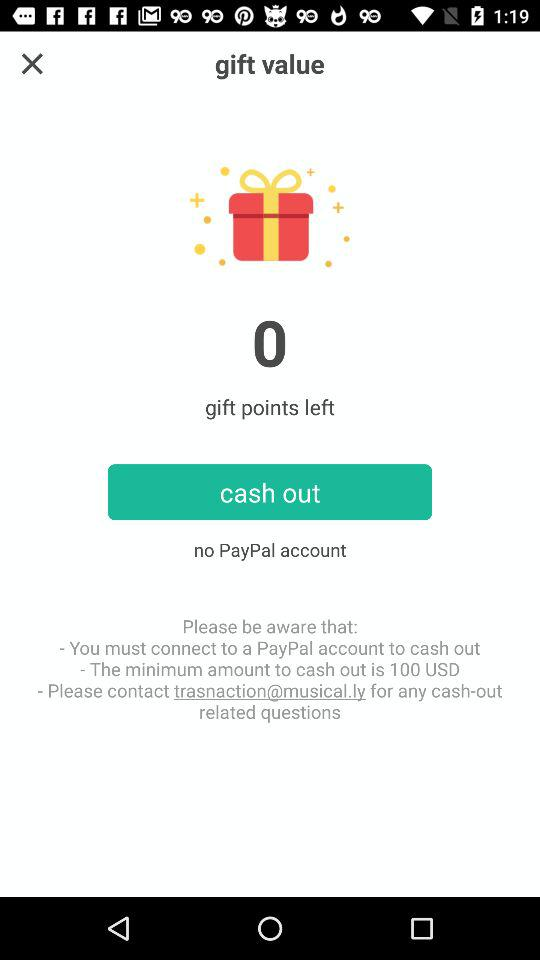What is the smallest amount that can be withdrawn? The smallest amount that can be withdrawn is 100 USD. 